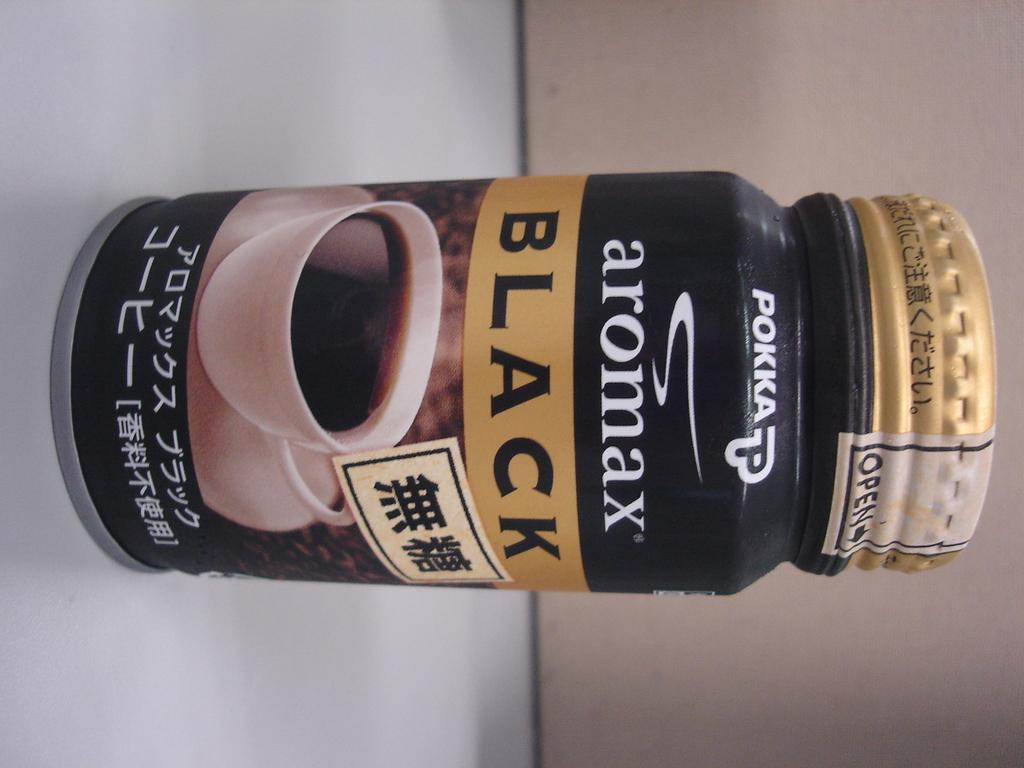Provide a one-sentence caption for the provided image. a container of POKKA aromax BLACK coffee related item. 